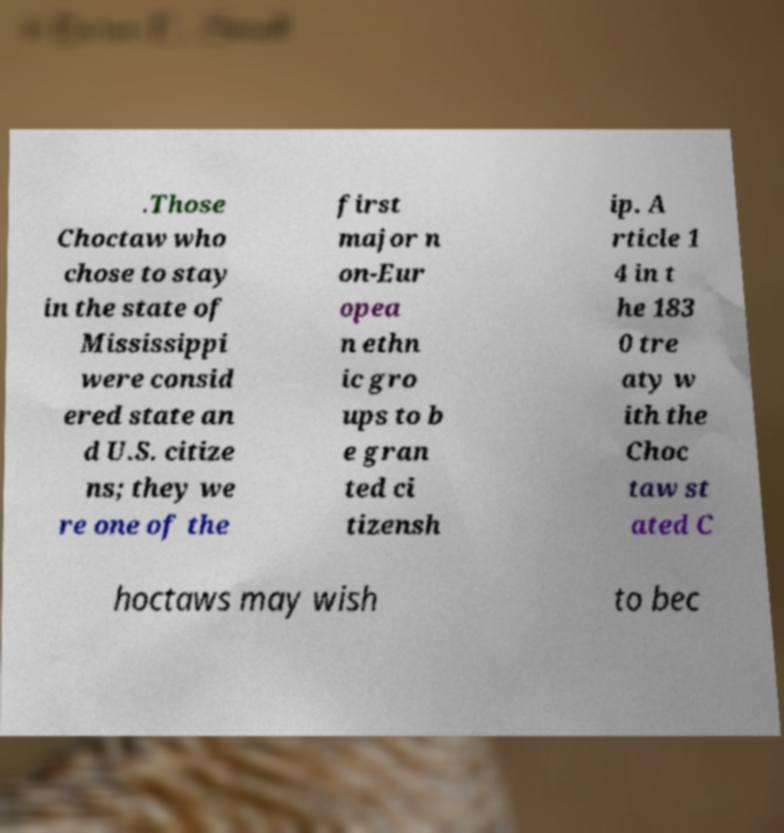Please read and relay the text visible in this image. What does it say? .Those Choctaw who chose to stay in the state of Mississippi were consid ered state an d U.S. citize ns; they we re one of the first major n on-Eur opea n ethn ic gro ups to b e gran ted ci tizensh ip. A rticle 1 4 in t he 183 0 tre aty w ith the Choc taw st ated C hoctaws may wish to bec 